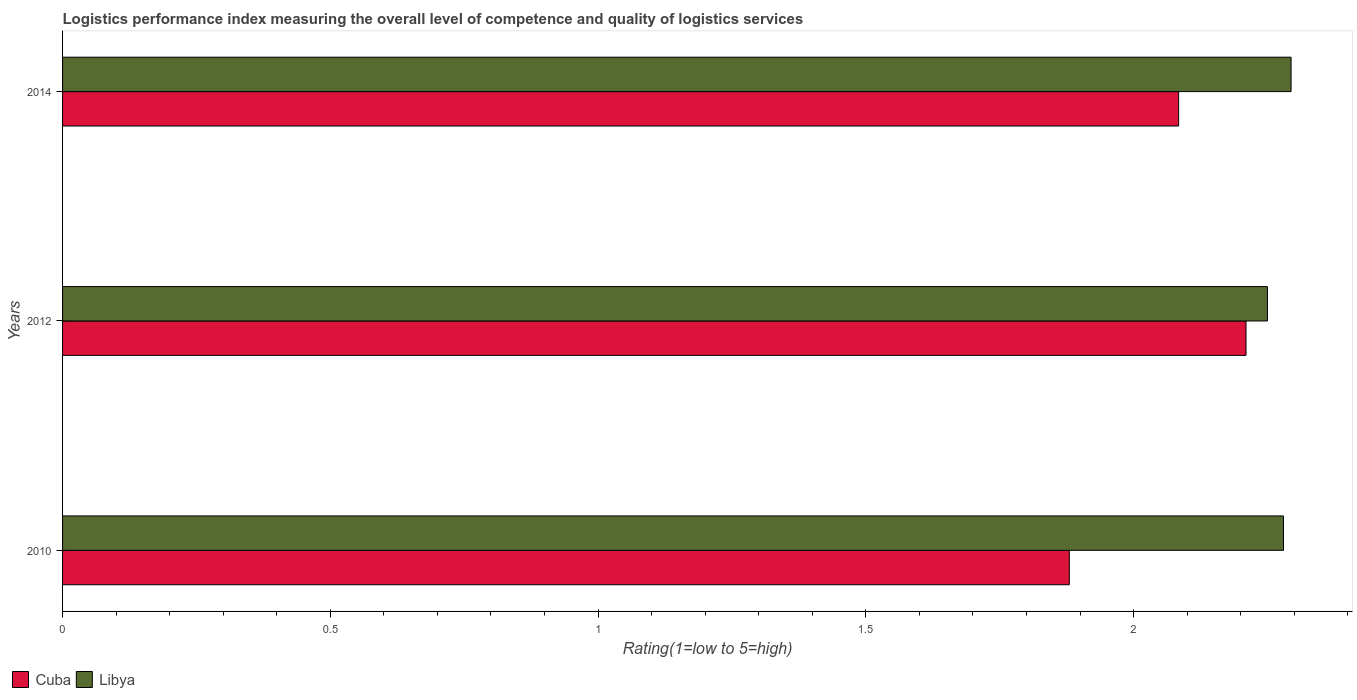How many different coloured bars are there?
Your response must be concise. 2. How many bars are there on the 1st tick from the bottom?
Provide a short and direct response. 2. What is the label of the 3rd group of bars from the top?
Ensure brevity in your answer.  2010. What is the Logistic performance index in Cuba in 2010?
Keep it short and to the point. 1.88. Across all years, what is the maximum Logistic performance index in Libya?
Keep it short and to the point. 2.29. Across all years, what is the minimum Logistic performance index in Libya?
Your answer should be compact. 2.25. What is the total Logistic performance index in Libya in the graph?
Give a very brief answer. 6.82. What is the difference between the Logistic performance index in Libya in 2010 and that in 2014?
Make the answer very short. -0.01. What is the difference between the Logistic performance index in Libya in 2010 and the Logistic performance index in Cuba in 2014?
Keep it short and to the point. 0.2. What is the average Logistic performance index in Libya per year?
Offer a very short reply. 2.27. In the year 2010, what is the difference between the Logistic performance index in Cuba and Logistic performance index in Libya?
Ensure brevity in your answer.  -0.4. In how many years, is the Logistic performance index in Cuba greater than 0.1 ?
Offer a very short reply. 3. What is the ratio of the Logistic performance index in Libya in 2012 to that in 2014?
Offer a very short reply. 0.98. Is the Logistic performance index in Cuba in 2010 less than that in 2012?
Offer a terse response. Yes. Is the difference between the Logistic performance index in Cuba in 2010 and 2012 greater than the difference between the Logistic performance index in Libya in 2010 and 2012?
Your response must be concise. No. What is the difference between the highest and the second highest Logistic performance index in Cuba?
Offer a very short reply. 0.13. What is the difference between the highest and the lowest Logistic performance index in Cuba?
Your answer should be compact. 0.33. In how many years, is the Logistic performance index in Cuba greater than the average Logistic performance index in Cuba taken over all years?
Your answer should be very brief. 2. Is the sum of the Logistic performance index in Cuba in 2012 and 2014 greater than the maximum Logistic performance index in Libya across all years?
Provide a succinct answer. Yes. What does the 2nd bar from the top in 2012 represents?
Give a very brief answer. Cuba. What does the 1st bar from the bottom in 2010 represents?
Make the answer very short. Cuba. How many bars are there?
Offer a very short reply. 6. How many years are there in the graph?
Make the answer very short. 3. What is the difference between two consecutive major ticks on the X-axis?
Make the answer very short. 0.5. Are the values on the major ticks of X-axis written in scientific E-notation?
Provide a succinct answer. No. Does the graph contain grids?
Your answer should be compact. No. How are the legend labels stacked?
Ensure brevity in your answer.  Horizontal. What is the title of the graph?
Your answer should be very brief. Logistics performance index measuring the overall level of competence and quality of logistics services. Does "Barbados" appear as one of the legend labels in the graph?
Your answer should be very brief. No. What is the label or title of the X-axis?
Keep it short and to the point. Rating(1=low to 5=high). What is the Rating(1=low to 5=high) of Cuba in 2010?
Make the answer very short. 1.88. What is the Rating(1=low to 5=high) of Libya in 2010?
Your answer should be compact. 2.28. What is the Rating(1=low to 5=high) of Cuba in 2012?
Make the answer very short. 2.21. What is the Rating(1=low to 5=high) in Libya in 2012?
Keep it short and to the point. 2.25. What is the Rating(1=low to 5=high) of Cuba in 2014?
Ensure brevity in your answer.  2.08. What is the Rating(1=low to 5=high) in Libya in 2014?
Provide a short and direct response. 2.29. Across all years, what is the maximum Rating(1=low to 5=high) in Cuba?
Offer a very short reply. 2.21. Across all years, what is the maximum Rating(1=low to 5=high) in Libya?
Your response must be concise. 2.29. Across all years, what is the minimum Rating(1=low to 5=high) of Cuba?
Offer a terse response. 1.88. Across all years, what is the minimum Rating(1=low to 5=high) of Libya?
Give a very brief answer. 2.25. What is the total Rating(1=low to 5=high) in Cuba in the graph?
Your answer should be compact. 6.17. What is the total Rating(1=low to 5=high) in Libya in the graph?
Your answer should be compact. 6.82. What is the difference between the Rating(1=low to 5=high) in Cuba in 2010 and that in 2012?
Ensure brevity in your answer.  -0.33. What is the difference between the Rating(1=low to 5=high) of Libya in 2010 and that in 2012?
Your response must be concise. 0.03. What is the difference between the Rating(1=low to 5=high) in Cuba in 2010 and that in 2014?
Offer a very short reply. -0.2. What is the difference between the Rating(1=low to 5=high) in Libya in 2010 and that in 2014?
Provide a succinct answer. -0.01. What is the difference between the Rating(1=low to 5=high) in Cuba in 2012 and that in 2014?
Provide a short and direct response. 0.13. What is the difference between the Rating(1=low to 5=high) of Libya in 2012 and that in 2014?
Offer a very short reply. -0.04. What is the difference between the Rating(1=low to 5=high) of Cuba in 2010 and the Rating(1=low to 5=high) of Libya in 2012?
Make the answer very short. -0.37. What is the difference between the Rating(1=low to 5=high) in Cuba in 2010 and the Rating(1=low to 5=high) in Libya in 2014?
Provide a short and direct response. -0.41. What is the difference between the Rating(1=low to 5=high) of Cuba in 2012 and the Rating(1=low to 5=high) of Libya in 2014?
Offer a terse response. -0.08. What is the average Rating(1=low to 5=high) of Cuba per year?
Offer a very short reply. 2.06. What is the average Rating(1=low to 5=high) in Libya per year?
Provide a short and direct response. 2.27. In the year 2012, what is the difference between the Rating(1=low to 5=high) of Cuba and Rating(1=low to 5=high) of Libya?
Ensure brevity in your answer.  -0.04. In the year 2014, what is the difference between the Rating(1=low to 5=high) in Cuba and Rating(1=low to 5=high) in Libya?
Keep it short and to the point. -0.21. What is the ratio of the Rating(1=low to 5=high) of Cuba in 2010 to that in 2012?
Offer a terse response. 0.85. What is the ratio of the Rating(1=low to 5=high) of Libya in 2010 to that in 2012?
Your answer should be very brief. 1.01. What is the ratio of the Rating(1=low to 5=high) of Cuba in 2010 to that in 2014?
Provide a short and direct response. 0.9. What is the ratio of the Rating(1=low to 5=high) in Libya in 2010 to that in 2014?
Keep it short and to the point. 0.99. What is the ratio of the Rating(1=low to 5=high) in Cuba in 2012 to that in 2014?
Your response must be concise. 1.06. What is the ratio of the Rating(1=low to 5=high) in Libya in 2012 to that in 2014?
Keep it short and to the point. 0.98. What is the difference between the highest and the second highest Rating(1=low to 5=high) of Cuba?
Your response must be concise. 0.13. What is the difference between the highest and the second highest Rating(1=low to 5=high) of Libya?
Make the answer very short. 0.01. What is the difference between the highest and the lowest Rating(1=low to 5=high) in Cuba?
Make the answer very short. 0.33. What is the difference between the highest and the lowest Rating(1=low to 5=high) in Libya?
Make the answer very short. 0.04. 